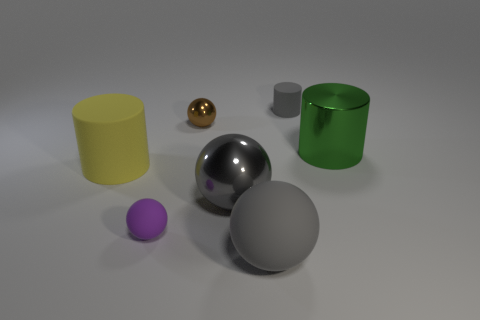There is a cylinder that is the same color as the big shiny ball; what size is it?
Your answer should be very brief. Small. What number of things are rubber objects in front of the yellow matte object or small brown metallic cylinders?
Provide a succinct answer. 2. Does the gray sphere that is behind the purple matte thing have the same material as the tiny purple thing?
Offer a terse response. No. Does the tiny gray object have the same shape as the small purple object?
Offer a terse response. No. There is a gray thing that is behind the green cylinder; what number of small rubber objects are behind it?
Your answer should be very brief. 0. There is a big green object that is the same shape as the large yellow object; what is its material?
Keep it short and to the point. Metal. Do the rubber cylinder left of the big gray matte object and the large shiny ball have the same color?
Offer a terse response. No. Does the purple thing have the same material as the gray sphere that is in front of the purple sphere?
Make the answer very short. Yes. The big thing left of the brown metallic thing has what shape?
Your response must be concise. Cylinder. How many other things are the same material as the brown object?
Offer a very short reply. 2. 